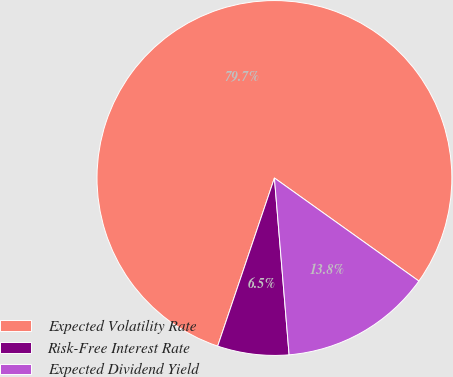Convert chart to OTSL. <chart><loc_0><loc_0><loc_500><loc_500><pie_chart><fcel>Expected Volatility Rate<fcel>Risk-Free Interest Rate<fcel>Expected Dividend Yield<nl><fcel>79.69%<fcel>6.5%<fcel>13.82%<nl></chart> 